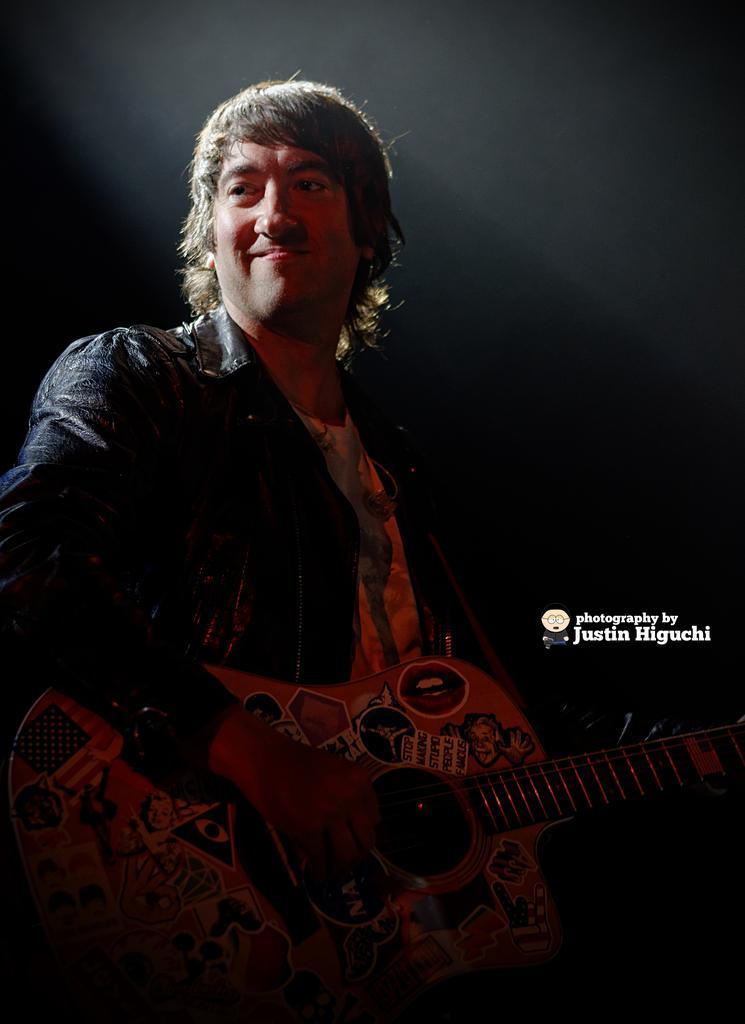Please provide a concise description of this image. This picture shows a man standing and playing a guitar and we see a smile on his face 